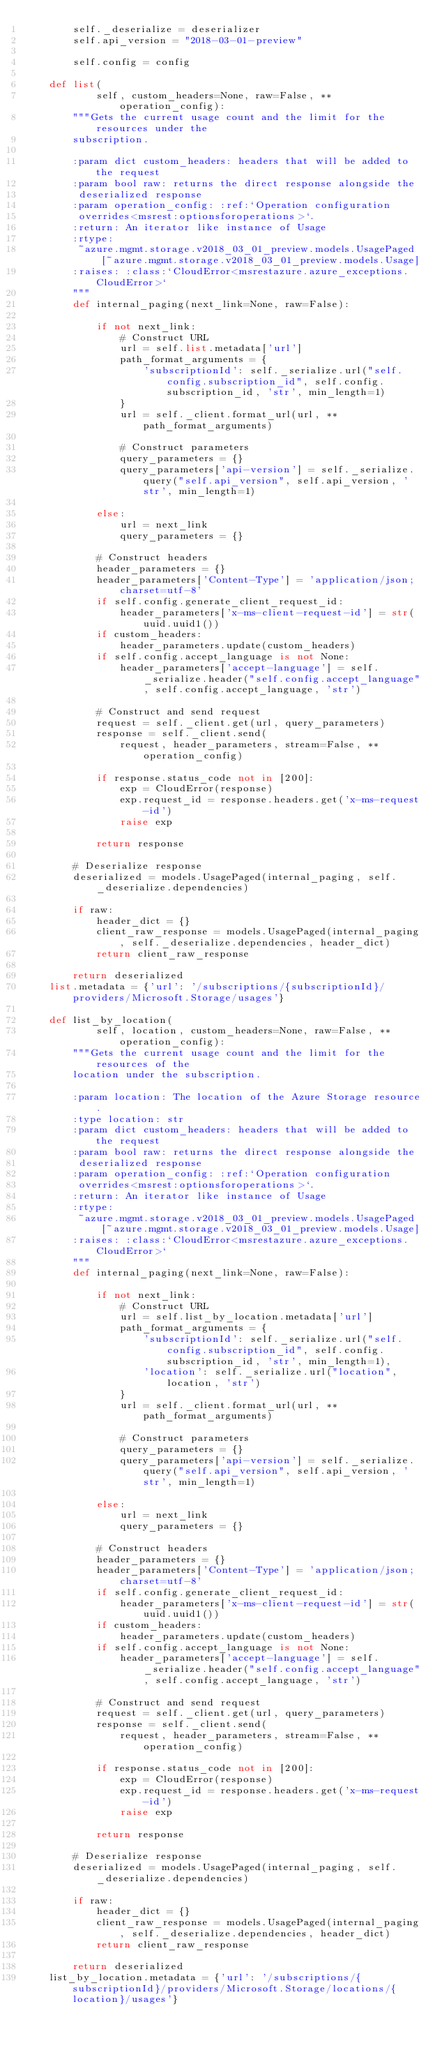<code> <loc_0><loc_0><loc_500><loc_500><_Python_>        self._deserialize = deserializer
        self.api_version = "2018-03-01-preview"

        self.config = config

    def list(
            self, custom_headers=None, raw=False, **operation_config):
        """Gets the current usage count and the limit for the resources under the
        subscription.

        :param dict custom_headers: headers that will be added to the request
        :param bool raw: returns the direct response alongside the
         deserialized response
        :param operation_config: :ref:`Operation configuration
         overrides<msrest:optionsforoperations>`.
        :return: An iterator like instance of Usage
        :rtype:
         ~azure.mgmt.storage.v2018_03_01_preview.models.UsagePaged[~azure.mgmt.storage.v2018_03_01_preview.models.Usage]
        :raises: :class:`CloudError<msrestazure.azure_exceptions.CloudError>`
        """
        def internal_paging(next_link=None, raw=False):

            if not next_link:
                # Construct URL
                url = self.list.metadata['url']
                path_format_arguments = {
                    'subscriptionId': self._serialize.url("self.config.subscription_id", self.config.subscription_id, 'str', min_length=1)
                }
                url = self._client.format_url(url, **path_format_arguments)

                # Construct parameters
                query_parameters = {}
                query_parameters['api-version'] = self._serialize.query("self.api_version", self.api_version, 'str', min_length=1)

            else:
                url = next_link
                query_parameters = {}

            # Construct headers
            header_parameters = {}
            header_parameters['Content-Type'] = 'application/json; charset=utf-8'
            if self.config.generate_client_request_id:
                header_parameters['x-ms-client-request-id'] = str(uuid.uuid1())
            if custom_headers:
                header_parameters.update(custom_headers)
            if self.config.accept_language is not None:
                header_parameters['accept-language'] = self._serialize.header("self.config.accept_language", self.config.accept_language, 'str')

            # Construct and send request
            request = self._client.get(url, query_parameters)
            response = self._client.send(
                request, header_parameters, stream=False, **operation_config)

            if response.status_code not in [200]:
                exp = CloudError(response)
                exp.request_id = response.headers.get('x-ms-request-id')
                raise exp

            return response

        # Deserialize response
        deserialized = models.UsagePaged(internal_paging, self._deserialize.dependencies)

        if raw:
            header_dict = {}
            client_raw_response = models.UsagePaged(internal_paging, self._deserialize.dependencies, header_dict)
            return client_raw_response

        return deserialized
    list.metadata = {'url': '/subscriptions/{subscriptionId}/providers/Microsoft.Storage/usages'}

    def list_by_location(
            self, location, custom_headers=None, raw=False, **operation_config):
        """Gets the current usage count and the limit for the resources of the
        location under the subscription.

        :param location: The location of the Azure Storage resource.
        :type location: str
        :param dict custom_headers: headers that will be added to the request
        :param bool raw: returns the direct response alongside the
         deserialized response
        :param operation_config: :ref:`Operation configuration
         overrides<msrest:optionsforoperations>`.
        :return: An iterator like instance of Usage
        :rtype:
         ~azure.mgmt.storage.v2018_03_01_preview.models.UsagePaged[~azure.mgmt.storage.v2018_03_01_preview.models.Usage]
        :raises: :class:`CloudError<msrestazure.azure_exceptions.CloudError>`
        """
        def internal_paging(next_link=None, raw=False):

            if not next_link:
                # Construct URL
                url = self.list_by_location.metadata['url']
                path_format_arguments = {
                    'subscriptionId': self._serialize.url("self.config.subscription_id", self.config.subscription_id, 'str', min_length=1),
                    'location': self._serialize.url("location", location, 'str')
                }
                url = self._client.format_url(url, **path_format_arguments)

                # Construct parameters
                query_parameters = {}
                query_parameters['api-version'] = self._serialize.query("self.api_version", self.api_version, 'str', min_length=1)

            else:
                url = next_link
                query_parameters = {}

            # Construct headers
            header_parameters = {}
            header_parameters['Content-Type'] = 'application/json; charset=utf-8'
            if self.config.generate_client_request_id:
                header_parameters['x-ms-client-request-id'] = str(uuid.uuid1())
            if custom_headers:
                header_parameters.update(custom_headers)
            if self.config.accept_language is not None:
                header_parameters['accept-language'] = self._serialize.header("self.config.accept_language", self.config.accept_language, 'str')

            # Construct and send request
            request = self._client.get(url, query_parameters)
            response = self._client.send(
                request, header_parameters, stream=False, **operation_config)

            if response.status_code not in [200]:
                exp = CloudError(response)
                exp.request_id = response.headers.get('x-ms-request-id')
                raise exp

            return response

        # Deserialize response
        deserialized = models.UsagePaged(internal_paging, self._deserialize.dependencies)

        if raw:
            header_dict = {}
            client_raw_response = models.UsagePaged(internal_paging, self._deserialize.dependencies, header_dict)
            return client_raw_response

        return deserialized
    list_by_location.metadata = {'url': '/subscriptions/{subscriptionId}/providers/Microsoft.Storage/locations/{location}/usages'}
</code> 